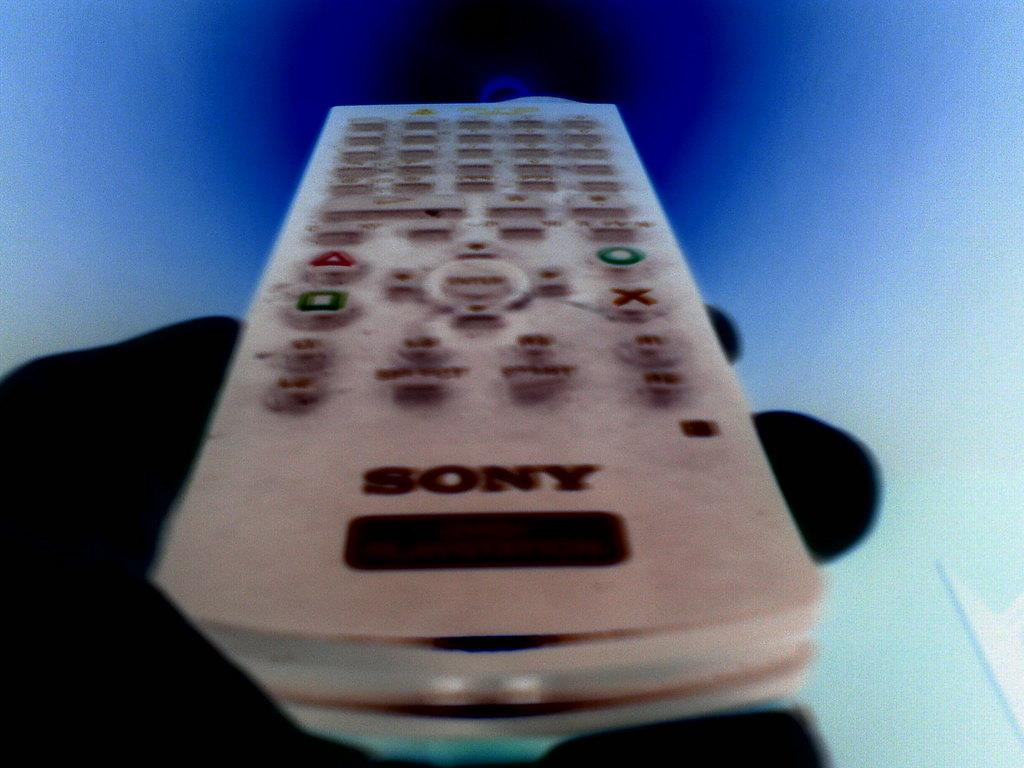What can be seen in the person's hand in the image? The person's hand is holding a remote in the image. What color is the background of the image? The background of the image is blue. What type of disgust can be seen on the person's face in the image? There is no person's face visible in the image, only their hand holding a remote. 